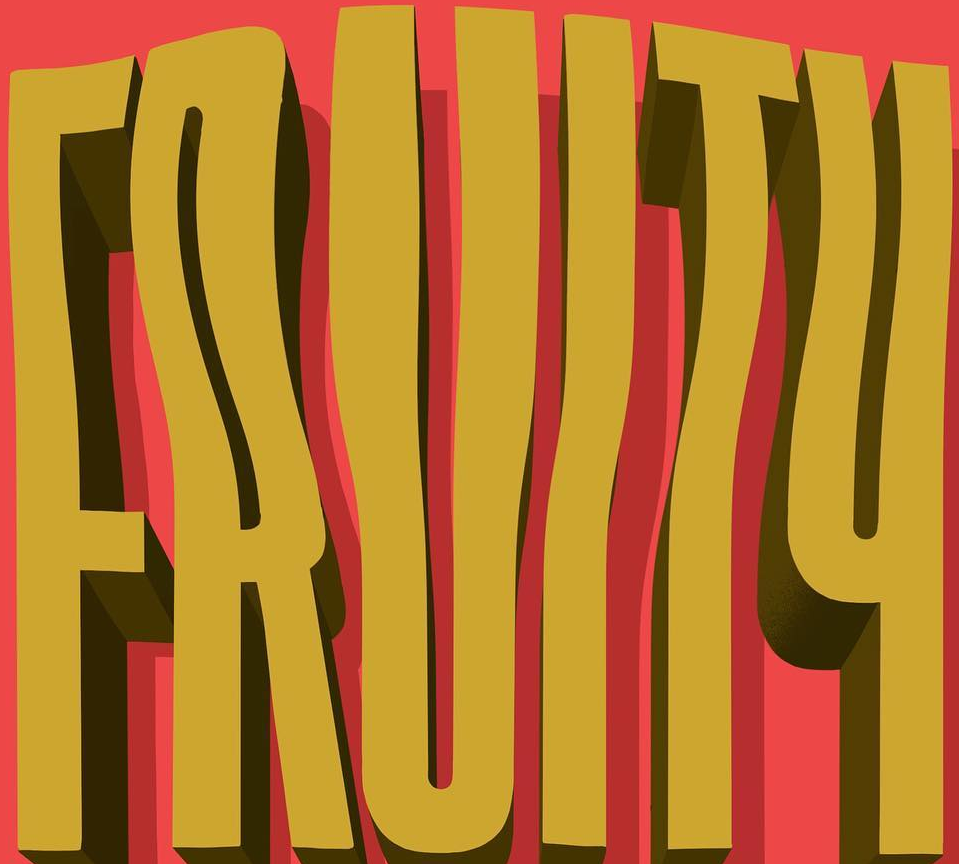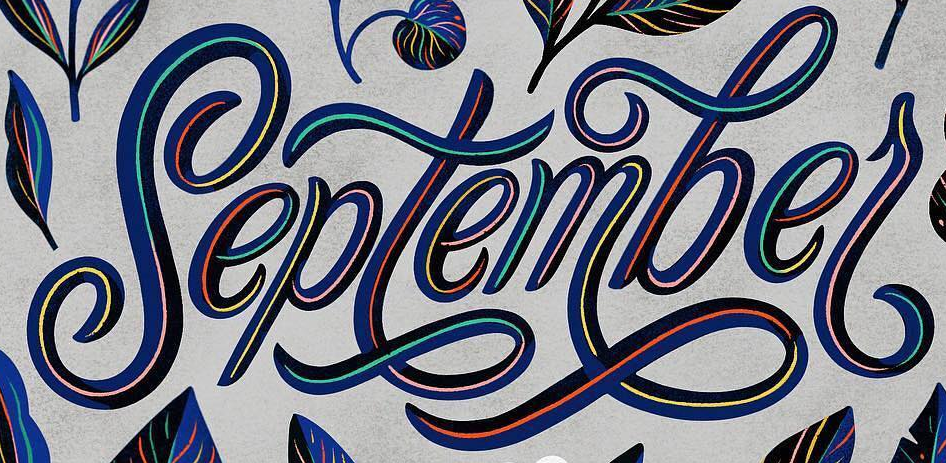Read the text from these images in sequence, separated by a semicolon. FRUITY; septembel 